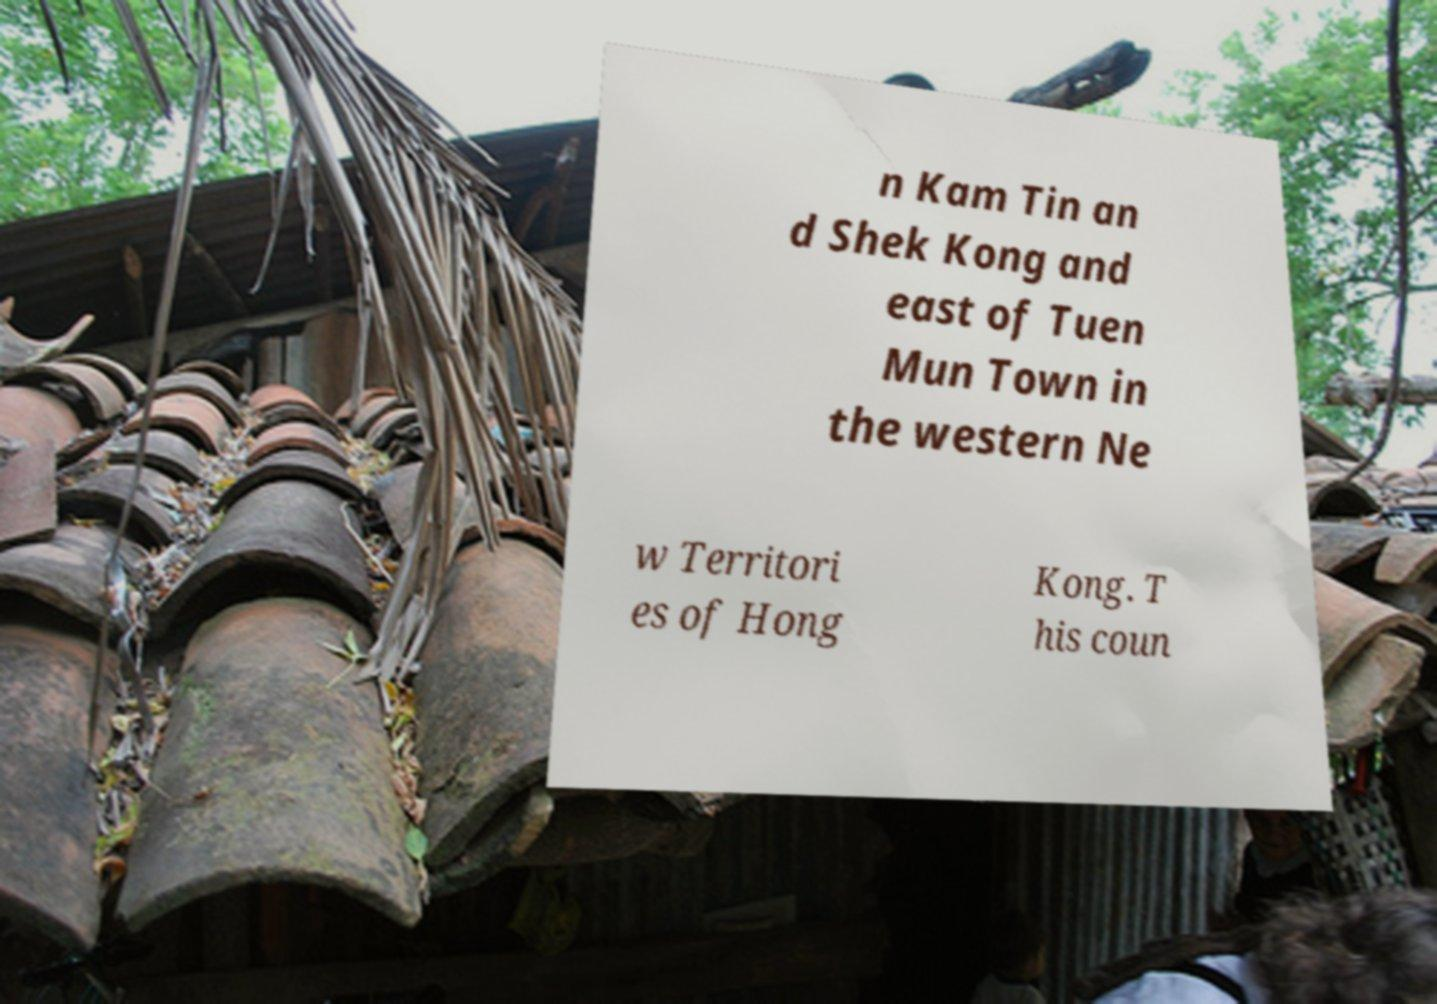There's text embedded in this image that I need extracted. Can you transcribe it verbatim? n Kam Tin an d Shek Kong and east of Tuen Mun Town in the western Ne w Territori es of Hong Kong. T his coun 